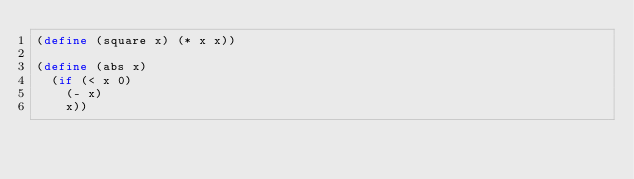Convert code to text. <code><loc_0><loc_0><loc_500><loc_500><_Scheme_>(define (square x) (* x x))

(define (abs x)
  (if (< x 0)
    (- x)
    x))
</code> 